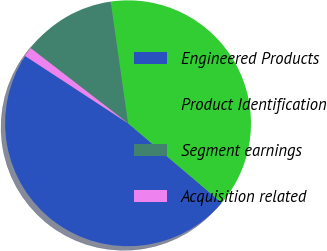Convert chart to OTSL. <chart><loc_0><loc_0><loc_500><loc_500><pie_chart><fcel>Engineered Products<fcel>Product Identification<fcel>Segment earnings<fcel>Acquisition related<nl><fcel>48.02%<fcel>38.46%<fcel>12.29%<fcel>1.23%<nl></chart> 